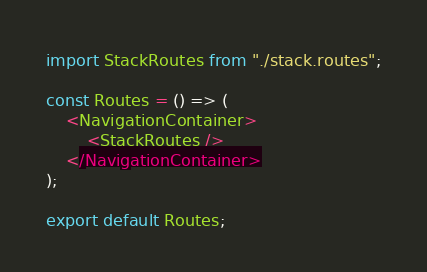<code> <loc_0><loc_0><loc_500><loc_500><_TypeScript_>import StackRoutes from "./stack.routes";

const Routes = () => (
	<NavigationContainer>
		<StackRoutes />
	</NavigationContainer>
);

export default Routes;</code> 